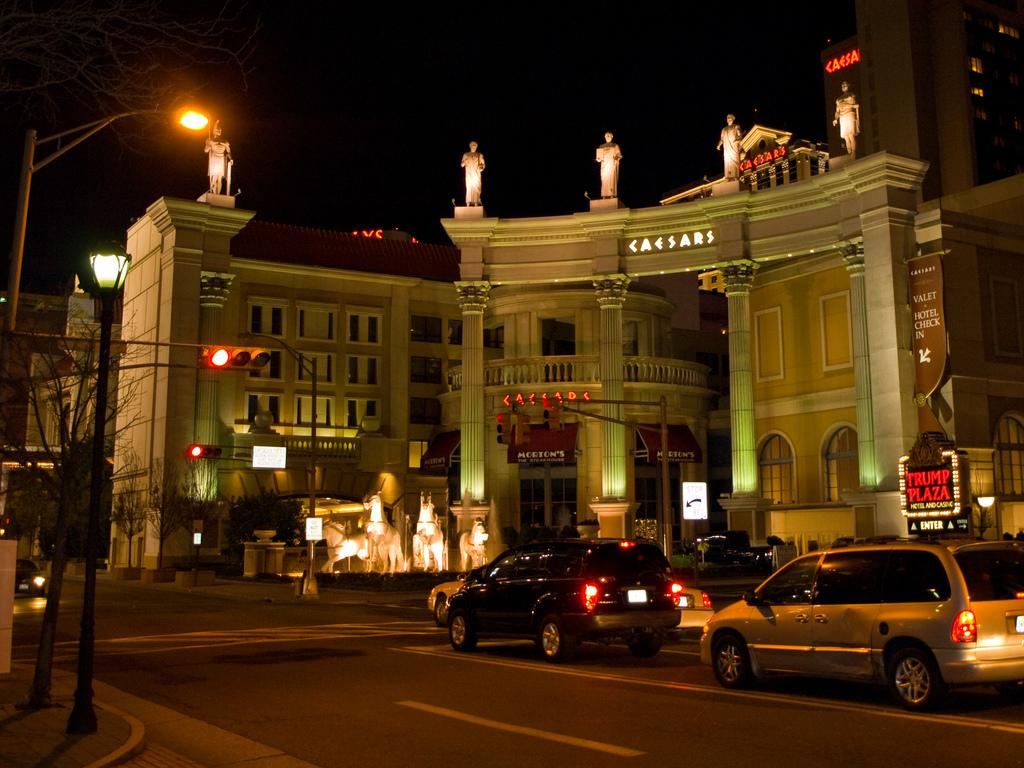<image>
Create a compact narrative representing the image presented. Cars in traffic are stopped at a red light by a large hotel and a sign that says Trump Plaza. 